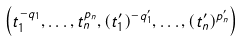Convert formula to latex. <formula><loc_0><loc_0><loc_500><loc_500>\left ( t _ { 1 } ^ { - q _ { 1 } } , \dots , t _ { n } ^ { p _ { n } } , ( t ^ { \prime } _ { 1 } ) ^ { - q ^ { \prime } _ { 1 } } , \dots , ( t ^ { \prime } _ { n } ) ^ { p ^ { \prime } _ { n } } \right )</formula> 